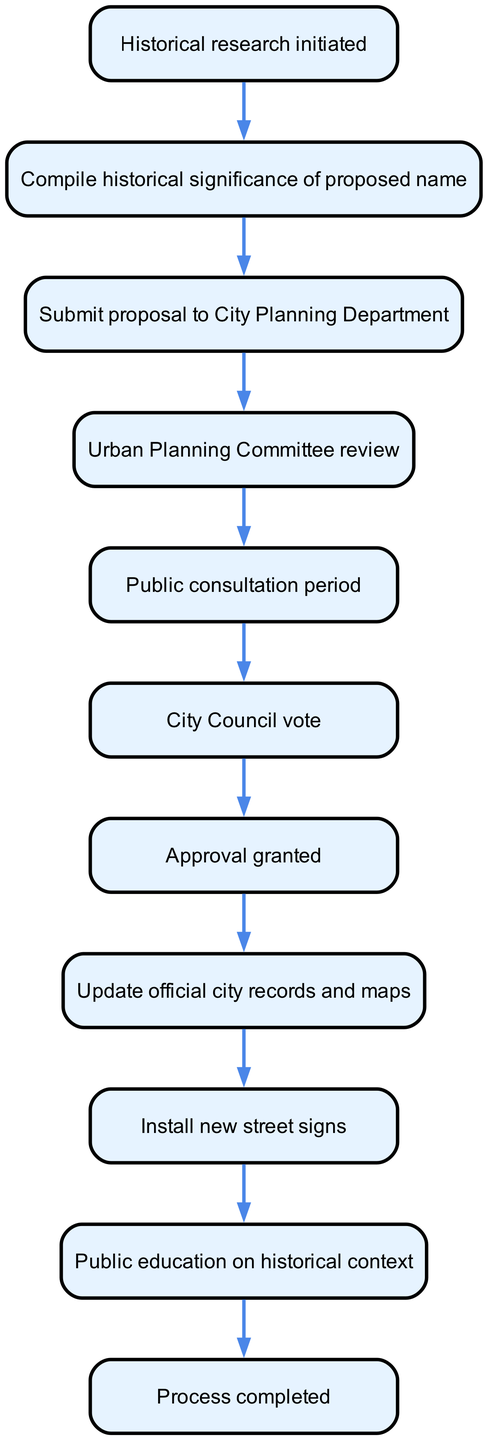What is the first step in the workflow? The diagram shows that the first step in the workflow is "Historical research initiated." This is indicated by the starting point of the flow chart.
Answer: Historical research initiated How many total nodes are present in the diagram? By counting all the elements represented in the diagram, we find there are ten nodes, each corresponding to a step in the workflow.
Answer: 10 What comes after public consultation period? The flow chart indicates that after the "Public consultation period," the next step is "City Council vote," which is a direct connection from one node to the next in the sequence.
Answer: City Council vote Which step follows approval granted? The diagram clearly states that after "Approval granted," the next action is "Update official city records and maps," which maintains the order of operations leading toward implementation.
Answer: Update official city records and maps What is the last step of the workflow? According to the flow chart, the final step is "Process completed," indicating the end of the workflow following all prior actions have been taken.
Answer: Process completed What is the purpose of the node labeled "Public education on historical context"? This node serves the purpose of informing the public about the historical significance of the name change, following the installation of the new street signs to enhance community awareness.
Answer: Informing the public about historical significance Identify the two nodes that are directly connected to the "Urban Planning Committee review." The node "Urban Planning Committee review" is connected to "Submit proposal to City Planning Department" before it and "Public consultation period" afterward, demonstrating the workflow's progression through these steps.
Answer: Submit proposal to City Planning Department and Public consultation period How does the flow chart end? The flow chart concludes with the node "Process completed," signifying that all steps have been executed leading to the resolution of the street name change proposal.
Answer: Process completed 